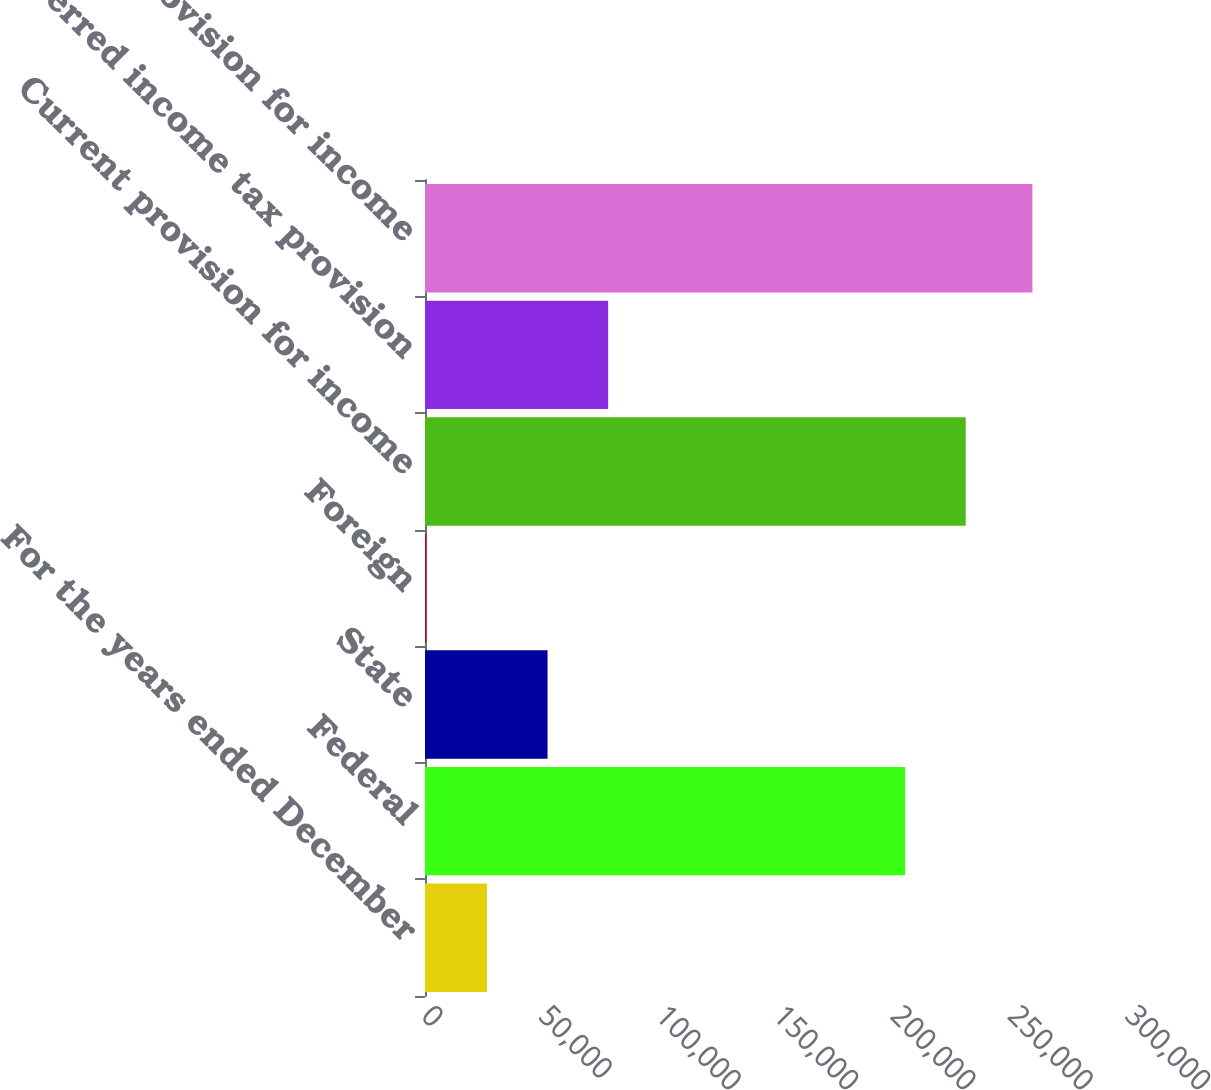Convert chart. <chart><loc_0><loc_0><loc_500><loc_500><bar_chart><fcel>For the years ended December<fcel>Federal<fcel>State<fcel>Foreign<fcel>Current provision for income<fcel>Deferred income tax provision<fcel>Total provision for income<nl><fcel>26398.8<fcel>204602<fcel>52226.6<fcel>571<fcel>230430<fcel>78054.4<fcel>258849<nl></chart> 